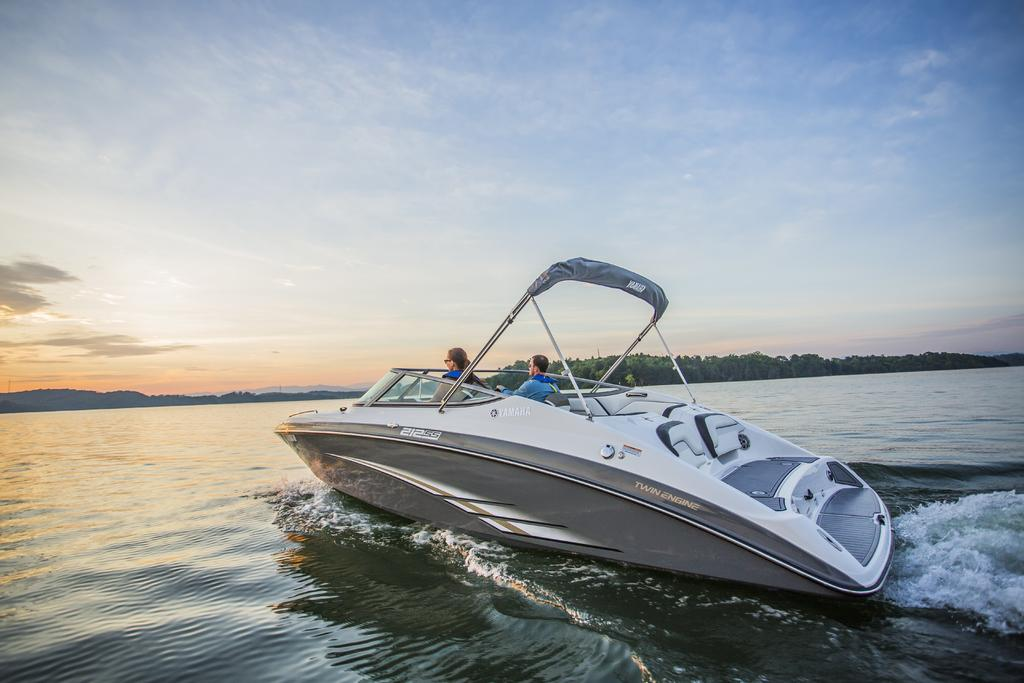What type of vehicle is in the image? There is a motor boat in the image. Where is the boat located? The boat is in the water. How many people are in the boat? There are two persons in the boat. What can be seen in the background of the image? There is an island in the background of the image. What is visible at the top of the image? The sky is visible at the top of the image. What is present at the bottom of the image? Water is present at the bottom of the image. What color crayon is being used to draw the boat in the image? There is no crayon present in the image; it is a photograph of a real motor boat. Who is the representative of the boat in the image? There is no representative present in the image; it is a photograph of a motor boat with two people in it. 